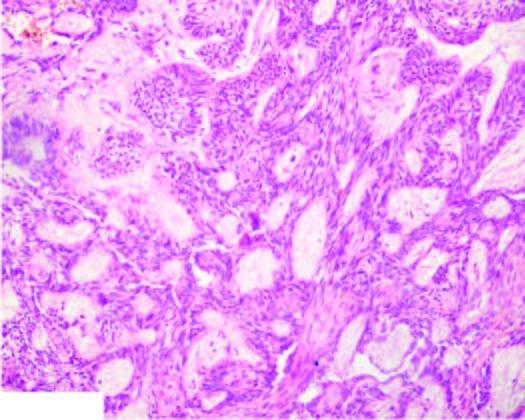do the squamous cells show central cystic change?
Answer the question using a single word or phrase. No 